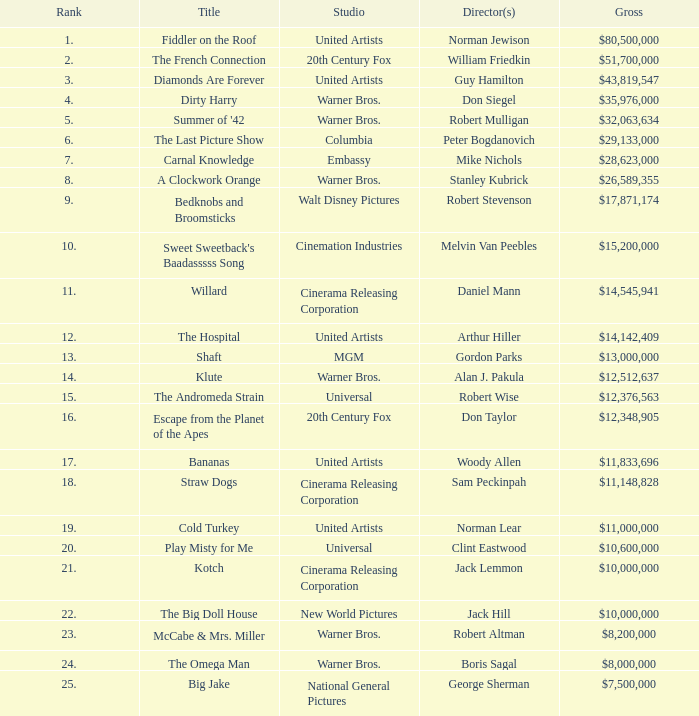What ranking has a sum of $35,976,000? 4.0. I'm looking to parse the entire table for insights. Could you assist me with that? {'header': ['Rank', 'Title', 'Studio', 'Director(s)', 'Gross'], 'rows': [['1.', 'Fiddler on the Roof', 'United Artists', 'Norman Jewison', '$80,500,000'], ['2.', 'The French Connection', '20th Century Fox', 'William Friedkin', '$51,700,000'], ['3.', 'Diamonds Are Forever', 'United Artists', 'Guy Hamilton', '$43,819,547'], ['4.', 'Dirty Harry', 'Warner Bros.', 'Don Siegel', '$35,976,000'], ['5.', "Summer of '42", 'Warner Bros.', 'Robert Mulligan', '$32,063,634'], ['6.', 'The Last Picture Show', 'Columbia', 'Peter Bogdanovich', '$29,133,000'], ['7.', 'Carnal Knowledge', 'Embassy', 'Mike Nichols', '$28,623,000'], ['8.', 'A Clockwork Orange', 'Warner Bros.', 'Stanley Kubrick', '$26,589,355'], ['9.', 'Bedknobs and Broomsticks', 'Walt Disney Pictures', 'Robert Stevenson', '$17,871,174'], ['10.', "Sweet Sweetback's Baadasssss Song", 'Cinemation Industries', 'Melvin Van Peebles', '$15,200,000'], ['11.', 'Willard', 'Cinerama Releasing Corporation', 'Daniel Mann', '$14,545,941'], ['12.', 'The Hospital', 'United Artists', 'Arthur Hiller', '$14,142,409'], ['13.', 'Shaft', 'MGM', 'Gordon Parks', '$13,000,000'], ['14.', 'Klute', 'Warner Bros.', 'Alan J. Pakula', '$12,512,637'], ['15.', 'The Andromeda Strain', 'Universal', 'Robert Wise', '$12,376,563'], ['16.', 'Escape from the Planet of the Apes', '20th Century Fox', 'Don Taylor', '$12,348,905'], ['17.', 'Bananas', 'United Artists', 'Woody Allen', '$11,833,696'], ['18.', 'Straw Dogs', 'Cinerama Releasing Corporation', 'Sam Peckinpah', '$11,148,828'], ['19.', 'Cold Turkey', 'United Artists', 'Norman Lear', '$11,000,000'], ['20.', 'Play Misty for Me', 'Universal', 'Clint Eastwood', '$10,600,000'], ['21.', 'Kotch', 'Cinerama Releasing Corporation', 'Jack Lemmon', '$10,000,000'], ['22.', 'The Big Doll House', 'New World Pictures', 'Jack Hill', '$10,000,000'], ['23.', 'McCabe & Mrs. Miller', 'Warner Bros.', 'Robert Altman', '$8,200,000'], ['24.', 'The Omega Man', 'Warner Bros.', 'Boris Sagal', '$8,000,000'], ['25.', 'Big Jake', 'National General Pictures', 'George Sherman', '$7,500,000']]} 